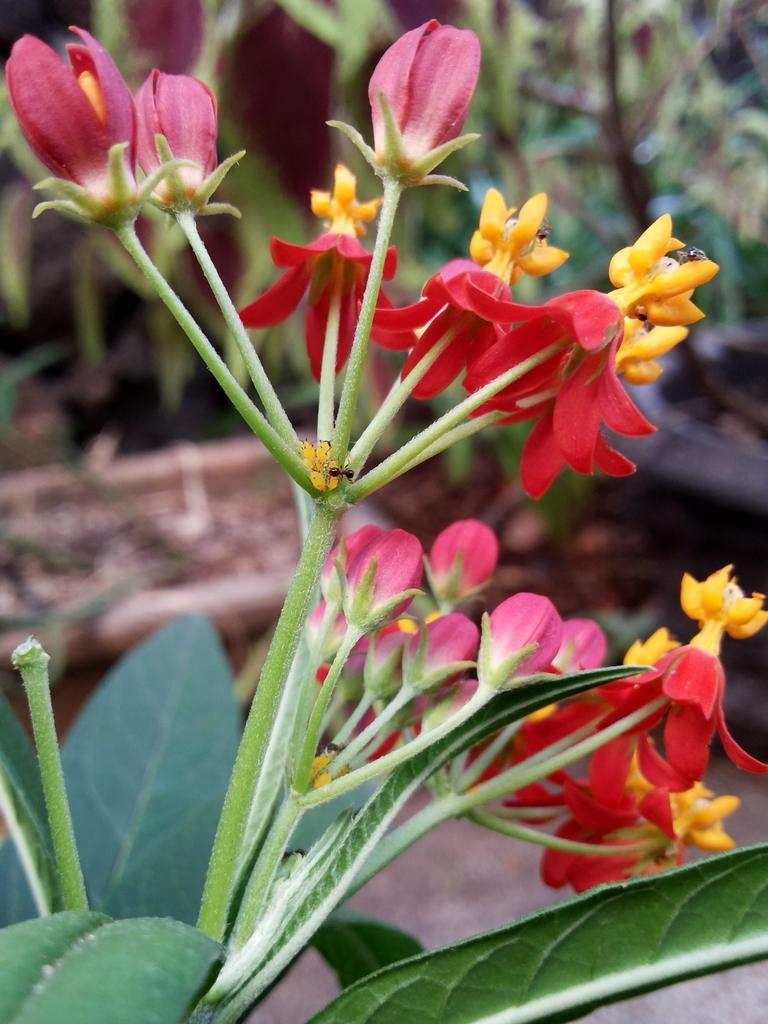What type of flowers can be seen on the plant in the image? The flowers on the plant in the image are in red, yellow, and pink colors. How many different colors of flowers are present on the plant? There are three different colors of flowers on the plant: red, yellow, and pink. What can be seen in the background of the image? There are many plants visible in the background of the image. How many units of memory are available in the image? There is no reference to memory or units in the image, as it features a plant with flowers and other plants in the background. 